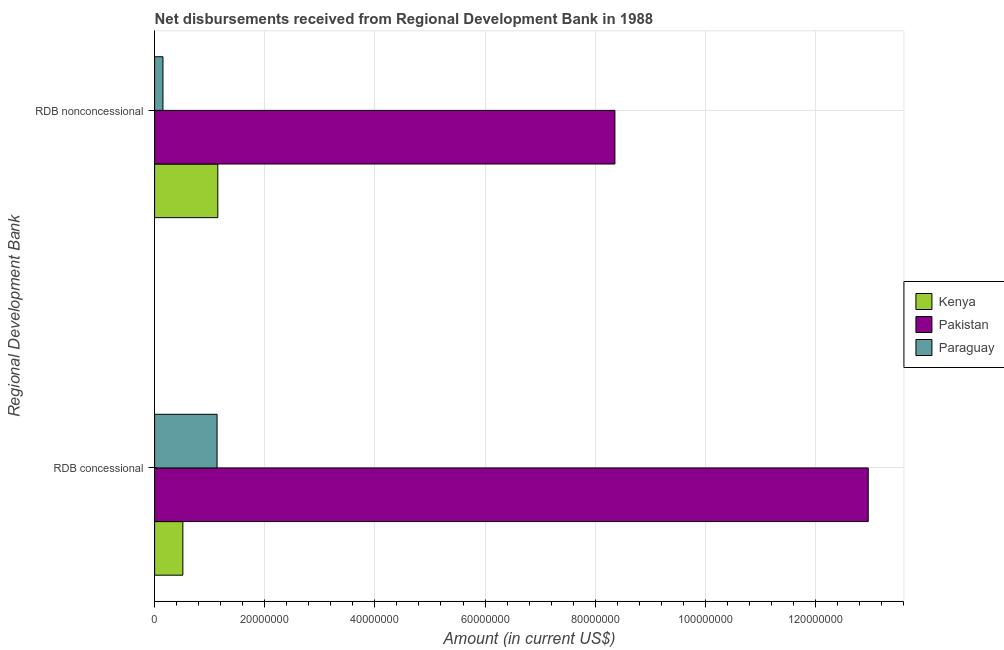How many different coloured bars are there?
Ensure brevity in your answer.  3. How many groups of bars are there?
Keep it short and to the point. 2. Are the number of bars per tick equal to the number of legend labels?
Your answer should be compact. Yes. Are the number of bars on each tick of the Y-axis equal?
Offer a terse response. Yes. How many bars are there on the 2nd tick from the top?
Ensure brevity in your answer.  3. What is the label of the 2nd group of bars from the top?
Ensure brevity in your answer.  RDB concessional. What is the net concessional disbursements from rdb in Kenya?
Give a very brief answer. 5.13e+06. Across all countries, what is the maximum net concessional disbursements from rdb?
Give a very brief answer. 1.30e+08. Across all countries, what is the minimum net concessional disbursements from rdb?
Your response must be concise. 5.13e+06. In which country was the net concessional disbursements from rdb minimum?
Give a very brief answer. Kenya. What is the total net non concessional disbursements from rdb in the graph?
Offer a very short reply. 9.66e+07. What is the difference between the net non concessional disbursements from rdb in Kenya and that in Paraguay?
Offer a very short reply. 9.96e+06. What is the difference between the net concessional disbursements from rdb in Paraguay and the net non concessional disbursements from rdb in Kenya?
Offer a terse response. -1.34e+05. What is the average net non concessional disbursements from rdb per country?
Your answer should be compact. 3.22e+07. What is the difference between the net concessional disbursements from rdb and net non concessional disbursements from rdb in Paraguay?
Keep it short and to the point. 9.83e+06. What is the ratio of the net concessional disbursements from rdb in Paraguay to that in Pakistan?
Provide a short and direct response. 0.09. What does the 1st bar from the top in RDB nonconcessional represents?
Provide a short and direct response. Paraguay. What does the 3rd bar from the bottom in RDB nonconcessional represents?
Offer a terse response. Paraguay. How many bars are there?
Keep it short and to the point. 6. Are all the bars in the graph horizontal?
Provide a succinct answer. Yes. How many legend labels are there?
Offer a very short reply. 3. What is the title of the graph?
Make the answer very short. Net disbursements received from Regional Development Bank in 1988. Does "Lebanon" appear as one of the legend labels in the graph?
Offer a terse response. No. What is the label or title of the Y-axis?
Offer a terse response. Regional Development Bank. What is the Amount (in current US$) of Kenya in RDB concessional?
Make the answer very short. 5.13e+06. What is the Amount (in current US$) in Pakistan in RDB concessional?
Give a very brief answer. 1.30e+08. What is the Amount (in current US$) of Paraguay in RDB concessional?
Ensure brevity in your answer.  1.13e+07. What is the Amount (in current US$) of Kenya in RDB nonconcessional?
Provide a succinct answer. 1.15e+07. What is the Amount (in current US$) of Pakistan in RDB nonconcessional?
Give a very brief answer. 8.36e+07. What is the Amount (in current US$) in Paraguay in RDB nonconcessional?
Ensure brevity in your answer.  1.52e+06. Across all Regional Development Bank, what is the maximum Amount (in current US$) in Kenya?
Give a very brief answer. 1.15e+07. Across all Regional Development Bank, what is the maximum Amount (in current US$) in Pakistan?
Ensure brevity in your answer.  1.30e+08. Across all Regional Development Bank, what is the maximum Amount (in current US$) in Paraguay?
Ensure brevity in your answer.  1.13e+07. Across all Regional Development Bank, what is the minimum Amount (in current US$) of Kenya?
Give a very brief answer. 5.13e+06. Across all Regional Development Bank, what is the minimum Amount (in current US$) in Pakistan?
Offer a very short reply. 8.36e+07. Across all Regional Development Bank, what is the minimum Amount (in current US$) in Paraguay?
Provide a short and direct response. 1.52e+06. What is the total Amount (in current US$) in Kenya in the graph?
Provide a short and direct response. 1.66e+07. What is the total Amount (in current US$) of Pakistan in the graph?
Your answer should be very brief. 2.13e+08. What is the total Amount (in current US$) in Paraguay in the graph?
Offer a very short reply. 1.29e+07. What is the difference between the Amount (in current US$) in Kenya in RDB concessional and that in RDB nonconcessional?
Provide a succinct answer. -6.35e+06. What is the difference between the Amount (in current US$) of Pakistan in RDB concessional and that in RDB nonconcessional?
Your answer should be compact. 4.60e+07. What is the difference between the Amount (in current US$) of Paraguay in RDB concessional and that in RDB nonconcessional?
Your answer should be compact. 9.83e+06. What is the difference between the Amount (in current US$) of Kenya in RDB concessional and the Amount (in current US$) of Pakistan in RDB nonconcessional?
Give a very brief answer. -7.84e+07. What is the difference between the Amount (in current US$) in Kenya in RDB concessional and the Amount (in current US$) in Paraguay in RDB nonconcessional?
Offer a terse response. 3.61e+06. What is the difference between the Amount (in current US$) of Pakistan in RDB concessional and the Amount (in current US$) of Paraguay in RDB nonconcessional?
Your response must be concise. 1.28e+08. What is the average Amount (in current US$) of Kenya per Regional Development Bank?
Your answer should be compact. 8.30e+06. What is the average Amount (in current US$) of Pakistan per Regional Development Bank?
Give a very brief answer. 1.07e+08. What is the average Amount (in current US$) of Paraguay per Regional Development Bank?
Offer a very short reply. 6.43e+06. What is the difference between the Amount (in current US$) of Kenya and Amount (in current US$) of Pakistan in RDB concessional?
Provide a succinct answer. -1.24e+08. What is the difference between the Amount (in current US$) of Kenya and Amount (in current US$) of Paraguay in RDB concessional?
Keep it short and to the point. -6.21e+06. What is the difference between the Amount (in current US$) of Pakistan and Amount (in current US$) of Paraguay in RDB concessional?
Provide a short and direct response. 1.18e+08. What is the difference between the Amount (in current US$) of Kenya and Amount (in current US$) of Pakistan in RDB nonconcessional?
Make the answer very short. -7.21e+07. What is the difference between the Amount (in current US$) in Kenya and Amount (in current US$) in Paraguay in RDB nonconcessional?
Your answer should be compact. 9.96e+06. What is the difference between the Amount (in current US$) in Pakistan and Amount (in current US$) in Paraguay in RDB nonconcessional?
Ensure brevity in your answer.  8.21e+07. What is the ratio of the Amount (in current US$) of Kenya in RDB concessional to that in RDB nonconcessional?
Provide a succinct answer. 0.45. What is the ratio of the Amount (in current US$) in Pakistan in RDB concessional to that in RDB nonconcessional?
Give a very brief answer. 1.55. What is the ratio of the Amount (in current US$) in Paraguay in RDB concessional to that in RDB nonconcessional?
Your answer should be compact. 7.48. What is the difference between the highest and the second highest Amount (in current US$) in Kenya?
Keep it short and to the point. 6.35e+06. What is the difference between the highest and the second highest Amount (in current US$) in Pakistan?
Provide a short and direct response. 4.60e+07. What is the difference between the highest and the second highest Amount (in current US$) of Paraguay?
Your answer should be compact. 9.83e+06. What is the difference between the highest and the lowest Amount (in current US$) of Kenya?
Provide a short and direct response. 6.35e+06. What is the difference between the highest and the lowest Amount (in current US$) in Pakistan?
Ensure brevity in your answer.  4.60e+07. What is the difference between the highest and the lowest Amount (in current US$) of Paraguay?
Offer a terse response. 9.83e+06. 